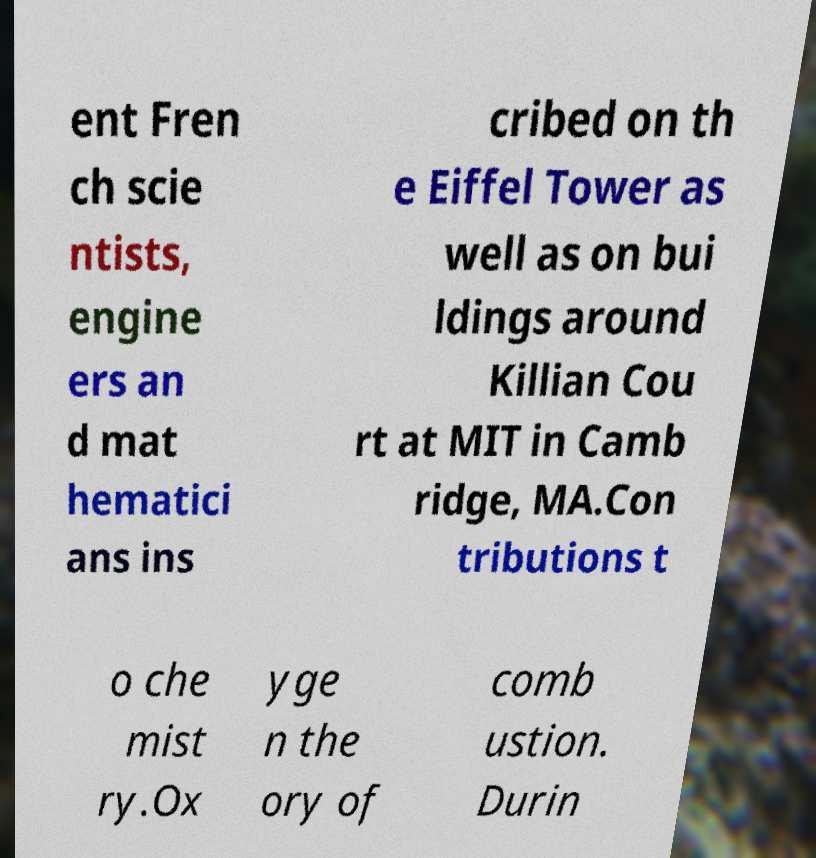Please read and relay the text visible in this image. What does it say? ent Fren ch scie ntists, engine ers an d mat hematici ans ins cribed on th e Eiffel Tower as well as on bui ldings around Killian Cou rt at MIT in Camb ridge, MA.Con tributions t o che mist ry.Ox yge n the ory of comb ustion. Durin 